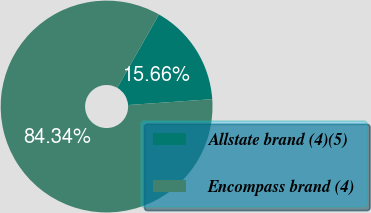<chart> <loc_0><loc_0><loc_500><loc_500><pie_chart><fcel>Allstate brand (4)(5)<fcel>Encompass brand (4)<nl><fcel>15.66%<fcel>84.34%<nl></chart> 